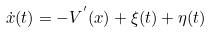<formula> <loc_0><loc_0><loc_500><loc_500>\dot { x } ( t ) = - V ^ { ^ { \prime } } ( x ) + \xi ( t ) + \eta ( t )</formula> 